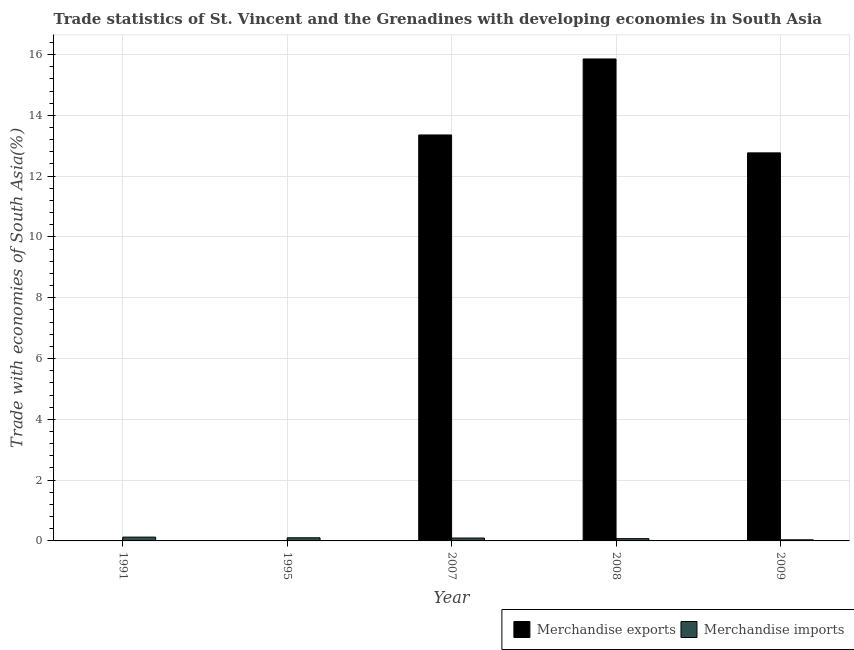How many different coloured bars are there?
Offer a terse response. 2. Are the number of bars per tick equal to the number of legend labels?
Your response must be concise. Yes. Are the number of bars on each tick of the X-axis equal?
Your response must be concise. Yes. How many bars are there on the 1st tick from the left?
Ensure brevity in your answer.  2. What is the label of the 5th group of bars from the left?
Provide a succinct answer. 2009. What is the merchandise exports in 1991?
Offer a very short reply. 0.01. Across all years, what is the maximum merchandise exports?
Provide a succinct answer. 15.86. Across all years, what is the minimum merchandise exports?
Your answer should be very brief. 0. What is the total merchandise imports in the graph?
Keep it short and to the point. 0.43. What is the difference between the merchandise exports in 1991 and that in 2008?
Your answer should be very brief. -15.84. What is the difference between the merchandise exports in 1991 and the merchandise imports in 2007?
Your answer should be very brief. -13.34. What is the average merchandise imports per year?
Offer a very short reply. 0.09. In the year 2009, what is the difference between the merchandise exports and merchandise imports?
Offer a terse response. 0. In how many years, is the merchandise exports greater than 3.6 %?
Your answer should be very brief. 3. What is the ratio of the merchandise exports in 1991 to that in 2009?
Your response must be concise. 0. Is the difference between the merchandise imports in 1995 and 2008 greater than the difference between the merchandise exports in 1995 and 2008?
Provide a short and direct response. No. What is the difference between the highest and the second highest merchandise exports?
Give a very brief answer. 2.5. What is the difference between the highest and the lowest merchandise imports?
Your answer should be very brief. 0.09. In how many years, is the merchandise exports greater than the average merchandise exports taken over all years?
Give a very brief answer. 3. Is the sum of the merchandise imports in 1991 and 1995 greater than the maximum merchandise exports across all years?
Provide a short and direct response. Yes. Are all the bars in the graph horizontal?
Offer a terse response. No. Are the values on the major ticks of Y-axis written in scientific E-notation?
Your answer should be compact. No. Does the graph contain grids?
Your response must be concise. Yes. What is the title of the graph?
Provide a short and direct response. Trade statistics of St. Vincent and the Grenadines with developing economies in South Asia. Does "Secondary school" appear as one of the legend labels in the graph?
Ensure brevity in your answer.  No. What is the label or title of the X-axis?
Your answer should be very brief. Year. What is the label or title of the Y-axis?
Provide a short and direct response. Trade with economies of South Asia(%). What is the Trade with economies of South Asia(%) of Merchandise exports in 1991?
Offer a very short reply. 0.01. What is the Trade with economies of South Asia(%) of Merchandise imports in 1991?
Offer a very short reply. 0.13. What is the Trade with economies of South Asia(%) of Merchandise exports in 1995?
Provide a succinct answer. 0. What is the Trade with economies of South Asia(%) of Merchandise imports in 1995?
Provide a succinct answer. 0.1. What is the Trade with economies of South Asia(%) of Merchandise exports in 2007?
Your answer should be very brief. 13.36. What is the Trade with economies of South Asia(%) of Merchandise imports in 2007?
Keep it short and to the point. 0.1. What is the Trade with economies of South Asia(%) of Merchandise exports in 2008?
Provide a short and direct response. 15.86. What is the Trade with economies of South Asia(%) in Merchandise imports in 2008?
Make the answer very short. 0.07. What is the Trade with economies of South Asia(%) of Merchandise exports in 2009?
Your answer should be compact. 12.77. What is the Trade with economies of South Asia(%) in Merchandise imports in 2009?
Your answer should be very brief. 0.04. Across all years, what is the maximum Trade with economies of South Asia(%) of Merchandise exports?
Keep it short and to the point. 15.86. Across all years, what is the maximum Trade with economies of South Asia(%) in Merchandise imports?
Ensure brevity in your answer.  0.13. Across all years, what is the minimum Trade with economies of South Asia(%) of Merchandise exports?
Ensure brevity in your answer.  0. Across all years, what is the minimum Trade with economies of South Asia(%) of Merchandise imports?
Give a very brief answer. 0.04. What is the total Trade with economies of South Asia(%) in Merchandise exports in the graph?
Offer a very short reply. 41.99. What is the total Trade with economies of South Asia(%) in Merchandise imports in the graph?
Offer a very short reply. 0.43. What is the difference between the Trade with economies of South Asia(%) of Merchandise exports in 1991 and that in 1995?
Your response must be concise. 0.01. What is the difference between the Trade with economies of South Asia(%) of Merchandise imports in 1991 and that in 1995?
Provide a short and direct response. 0.02. What is the difference between the Trade with economies of South Asia(%) in Merchandise exports in 1991 and that in 2007?
Provide a succinct answer. -13.34. What is the difference between the Trade with economies of South Asia(%) in Merchandise imports in 1991 and that in 2007?
Offer a very short reply. 0.03. What is the difference between the Trade with economies of South Asia(%) in Merchandise exports in 1991 and that in 2008?
Provide a short and direct response. -15.84. What is the difference between the Trade with economies of South Asia(%) of Merchandise imports in 1991 and that in 2008?
Offer a terse response. 0.05. What is the difference between the Trade with economies of South Asia(%) in Merchandise exports in 1991 and that in 2009?
Your response must be concise. -12.75. What is the difference between the Trade with economies of South Asia(%) in Merchandise imports in 1991 and that in 2009?
Provide a short and direct response. 0.09. What is the difference between the Trade with economies of South Asia(%) in Merchandise exports in 1995 and that in 2007?
Your answer should be compact. -13.35. What is the difference between the Trade with economies of South Asia(%) in Merchandise imports in 1995 and that in 2007?
Provide a short and direct response. 0.01. What is the difference between the Trade with economies of South Asia(%) in Merchandise exports in 1995 and that in 2008?
Give a very brief answer. -15.85. What is the difference between the Trade with economies of South Asia(%) of Merchandise imports in 1995 and that in 2008?
Keep it short and to the point. 0.03. What is the difference between the Trade with economies of South Asia(%) in Merchandise exports in 1995 and that in 2009?
Ensure brevity in your answer.  -12.76. What is the difference between the Trade with economies of South Asia(%) of Merchandise imports in 1995 and that in 2009?
Give a very brief answer. 0.07. What is the difference between the Trade with economies of South Asia(%) of Merchandise exports in 2007 and that in 2008?
Provide a short and direct response. -2.5. What is the difference between the Trade with economies of South Asia(%) of Merchandise imports in 2007 and that in 2008?
Make the answer very short. 0.02. What is the difference between the Trade with economies of South Asia(%) in Merchandise exports in 2007 and that in 2009?
Give a very brief answer. 0.59. What is the difference between the Trade with economies of South Asia(%) in Merchandise imports in 2007 and that in 2009?
Make the answer very short. 0.06. What is the difference between the Trade with economies of South Asia(%) of Merchandise exports in 2008 and that in 2009?
Give a very brief answer. 3.09. What is the difference between the Trade with economies of South Asia(%) in Merchandise imports in 2008 and that in 2009?
Offer a very short reply. 0.04. What is the difference between the Trade with economies of South Asia(%) of Merchandise exports in 1991 and the Trade with economies of South Asia(%) of Merchandise imports in 1995?
Provide a short and direct response. -0.09. What is the difference between the Trade with economies of South Asia(%) in Merchandise exports in 1991 and the Trade with economies of South Asia(%) in Merchandise imports in 2007?
Offer a terse response. -0.08. What is the difference between the Trade with economies of South Asia(%) of Merchandise exports in 1991 and the Trade with economies of South Asia(%) of Merchandise imports in 2008?
Keep it short and to the point. -0.06. What is the difference between the Trade with economies of South Asia(%) in Merchandise exports in 1991 and the Trade with economies of South Asia(%) in Merchandise imports in 2009?
Offer a very short reply. -0.02. What is the difference between the Trade with economies of South Asia(%) of Merchandise exports in 1995 and the Trade with economies of South Asia(%) of Merchandise imports in 2007?
Offer a very short reply. -0.09. What is the difference between the Trade with economies of South Asia(%) in Merchandise exports in 1995 and the Trade with economies of South Asia(%) in Merchandise imports in 2008?
Make the answer very short. -0.07. What is the difference between the Trade with economies of South Asia(%) in Merchandise exports in 1995 and the Trade with economies of South Asia(%) in Merchandise imports in 2009?
Ensure brevity in your answer.  -0.03. What is the difference between the Trade with economies of South Asia(%) in Merchandise exports in 2007 and the Trade with economies of South Asia(%) in Merchandise imports in 2008?
Make the answer very short. 13.28. What is the difference between the Trade with economies of South Asia(%) of Merchandise exports in 2007 and the Trade with economies of South Asia(%) of Merchandise imports in 2009?
Provide a succinct answer. 13.32. What is the difference between the Trade with economies of South Asia(%) of Merchandise exports in 2008 and the Trade with economies of South Asia(%) of Merchandise imports in 2009?
Ensure brevity in your answer.  15.82. What is the average Trade with economies of South Asia(%) in Merchandise exports per year?
Your answer should be compact. 8.4. What is the average Trade with economies of South Asia(%) in Merchandise imports per year?
Provide a short and direct response. 0.09. In the year 1991, what is the difference between the Trade with economies of South Asia(%) in Merchandise exports and Trade with economies of South Asia(%) in Merchandise imports?
Provide a succinct answer. -0.11. In the year 1995, what is the difference between the Trade with economies of South Asia(%) in Merchandise exports and Trade with economies of South Asia(%) in Merchandise imports?
Keep it short and to the point. -0.1. In the year 2007, what is the difference between the Trade with economies of South Asia(%) of Merchandise exports and Trade with economies of South Asia(%) of Merchandise imports?
Offer a terse response. 13.26. In the year 2008, what is the difference between the Trade with economies of South Asia(%) in Merchandise exports and Trade with economies of South Asia(%) in Merchandise imports?
Your answer should be compact. 15.78. In the year 2009, what is the difference between the Trade with economies of South Asia(%) in Merchandise exports and Trade with economies of South Asia(%) in Merchandise imports?
Your answer should be compact. 12.73. What is the ratio of the Trade with economies of South Asia(%) of Merchandise exports in 1991 to that in 1995?
Offer a terse response. 3.18. What is the ratio of the Trade with economies of South Asia(%) in Merchandise imports in 1991 to that in 1995?
Make the answer very short. 1.21. What is the ratio of the Trade with economies of South Asia(%) of Merchandise imports in 1991 to that in 2007?
Give a very brief answer. 1.32. What is the ratio of the Trade with economies of South Asia(%) in Merchandise exports in 1991 to that in 2008?
Your response must be concise. 0. What is the ratio of the Trade with economies of South Asia(%) in Merchandise imports in 1991 to that in 2008?
Offer a very short reply. 1.69. What is the ratio of the Trade with economies of South Asia(%) of Merchandise imports in 1991 to that in 2009?
Provide a short and direct response. 3.42. What is the ratio of the Trade with economies of South Asia(%) of Merchandise imports in 1995 to that in 2007?
Make the answer very short. 1.08. What is the ratio of the Trade with economies of South Asia(%) in Merchandise exports in 1995 to that in 2008?
Offer a terse response. 0. What is the ratio of the Trade with economies of South Asia(%) in Merchandise imports in 1995 to that in 2008?
Provide a succinct answer. 1.39. What is the ratio of the Trade with economies of South Asia(%) in Merchandise exports in 1995 to that in 2009?
Provide a succinct answer. 0. What is the ratio of the Trade with economies of South Asia(%) of Merchandise imports in 1995 to that in 2009?
Offer a very short reply. 2.82. What is the ratio of the Trade with economies of South Asia(%) of Merchandise exports in 2007 to that in 2008?
Provide a succinct answer. 0.84. What is the ratio of the Trade with economies of South Asia(%) in Merchandise imports in 2007 to that in 2008?
Provide a succinct answer. 1.28. What is the ratio of the Trade with economies of South Asia(%) of Merchandise exports in 2007 to that in 2009?
Make the answer very short. 1.05. What is the ratio of the Trade with economies of South Asia(%) in Merchandise imports in 2007 to that in 2009?
Your answer should be compact. 2.6. What is the ratio of the Trade with economies of South Asia(%) in Merchandise exports in 2008 to that in 2009?
Give a very brief answer. 1.24. What is the ratio of the Trade with economies of South Asia(%) of Merchandise imports in 2008 to that in 2009?
Offer a terse response. 2.02. What is the difference between the highest and the second highest Trade with economies of South Asia(%) of Merchandise exports?
Your answer should be very brief. 2.5. What is the difference between the highest and the second highest Trade with economies of South Asia(%) in Merchandise imports?
Give a very brief answer. 0.02. What is the difference between the highest and the lowest Trade with economies of South Asia(%) in Merchandise exports?
Offer a very short reply. 15.85. What is the difference between the highest and the lowest Trade with economies of South Asia(%) in Merchandise imports?
Offer a very short reply. 0.09. 